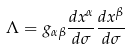Convert formula to latex. <formula><loc_0><loc_0><loc_500><loc_500>\Lambda = g _ { \alpha \beta } \frac { d x ^ { \alpha } } { d \sigma } \frac { d x ^ { \beta } } { d \sigma }</formula> 